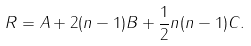<formula> <loc_0><loc_0><loc_500><loc_500>R = A + 2 ( n - 1 ) B + \frac { 1 } { 2 } n ( n - 1 ) C .</formula> 